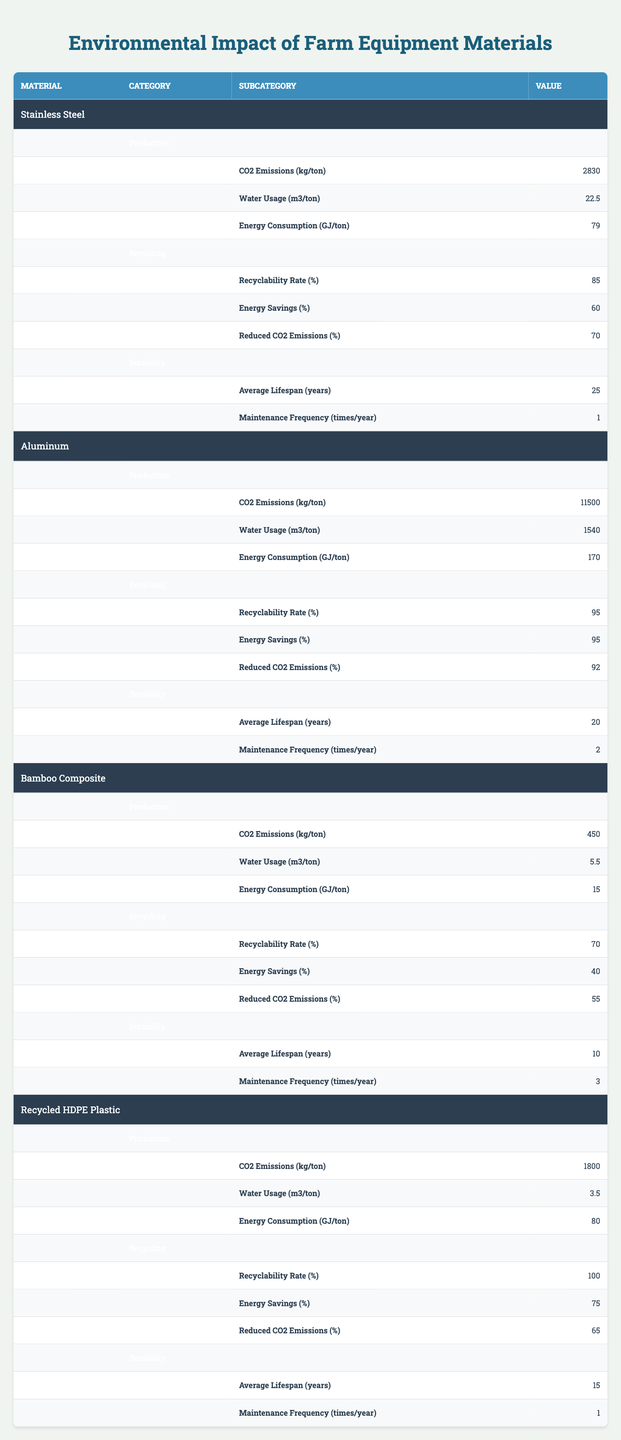What are the CO2 emissions for Aluminum production? According to the table, the CO2 emissions for Aluminum production are stated directly under the corresponding material and category. It shows that CO2 emissions for Aluminum production are 11,500 kg/ton.
Answer: 11,500 kg/ton Which material has the highest recyclability rate? By comparing the recyclability rates listed in the Recycling category for each material, Aluminum has a rate of 95%, which is the highest compared to Stainless Steel (85%), Bamboo Composite (70%), and Recycled HDPE Plastic (100%).
Answer: Recycled HDPE Plastic What is the difference in average lifespan between Stainless Steel and Bamboo Composite? The average lifespan of Stainless Steel is 25 years, while that of Bamboo Composite is 10 years. The difference can be calculated as 25 - 10 = 15 years.
Answer: 15 years Does the Bamboo Composite use more water than the Recycled HDPE Plastic in production? The table shows that Bamboo Composite uses 5.5 m3 of water per ton, while Recycled HDPE Plastic uses 3.5 m3. Since 5.5 is greater than 3.5, the Bamboo Composite does use more water in production.
Answer: Yes What is the total energy consumption for production across all materials? The energy consumption values for each material in production are 79 GJ/ton (Stainless Steel), 170 GJ/ton (Aluminum), 15 GJ/ton (Bamboo Composite), and 80 GJ/ton (Recycled HDPE Plastic). We sum these values: 79 + 170 + 15 + 80 = 344 GJ/ton for total energy consumption.
Answer: 344 GJ/ton Which material has the lowest CO2 emissions during production? By examining the CO2 emissions listed for each material, we find that Bamboo Composite has the lowest emissions at 450 kg/ton compared to others: Stainless Steel (2830 kg/ton), Aluminum (11500 kg/ton), and Recycled HDPE Plastic (1800 kg/ton).
Answer: Bamboo Composite What is the average maintenance frequency for all materials? The maintenance frequencies are listed as follows: Stainless Steel (1), Aluminum (2), Bamboo Composite (3), and Recycled HDPE Plastic (1). The sum is 1 + 2 + 3 + 1 = 7. The average is then calculated as 7 divided by 4 = 1.75 times/year.
Answer: 1.75 times/year How much CO2 can be reduced through recycling of Aluminum? The table indicates that Reduced CO2 Emissions for Aluminum recyclability is 92%. This means that 92% of the CO2 emissions can be reduced when Aluminum is recycled.
Answer: 92% Which material appears to be the most environmentally friendly based on the overall factors in the table and why? The Bamboo Composite shows the lowest CO2 emissions (450 kg/ton), lowest water usage (5.5 m3/ton), and excellent energy consumption (15 GJ/ton), although it has lower recyclability. It also has a lower average lifespan of 10 years compared to other materials, which might not be favorable for longevity but offers an environmentally friendly production aspect.
Answer: Bamboo Composite Which material requires the highest frequency of maintenance? The maintenance frequencies are 1 for Stainless Steel, 2 for Aluminum, 3 for Bamboo Composite, and 1 for Recycled HDPE Plastic. By reviewing these values, we see that Bamboo Composite requires the highest frequency of maintenance.
Answer: Bamboo Composite 